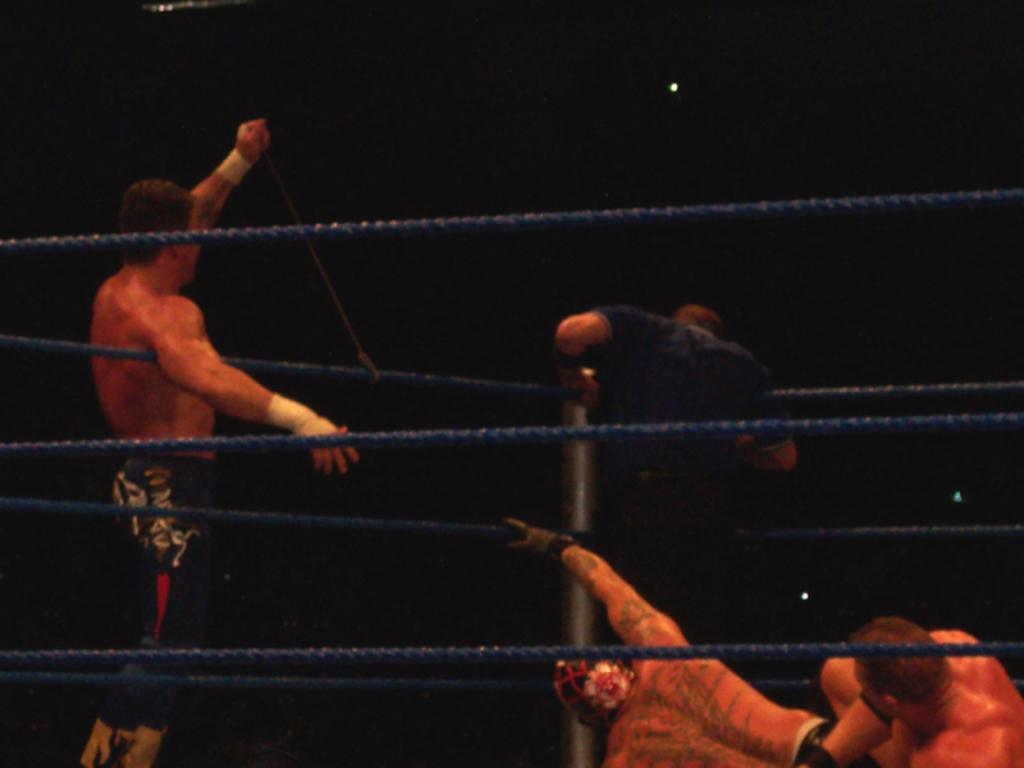How many people are in the image? There is a group of people in the image, but the exact number is not specified. What are the people in the image doing? The people are playing a game. What color are the ropes in the image? The ropes in the image are blue. What can be observed about the background of the image? The background of the image is dark. What type of territory is being claimed by the mailbox in the image? There is no mailbox present in the image, so no territory is being claimed. 